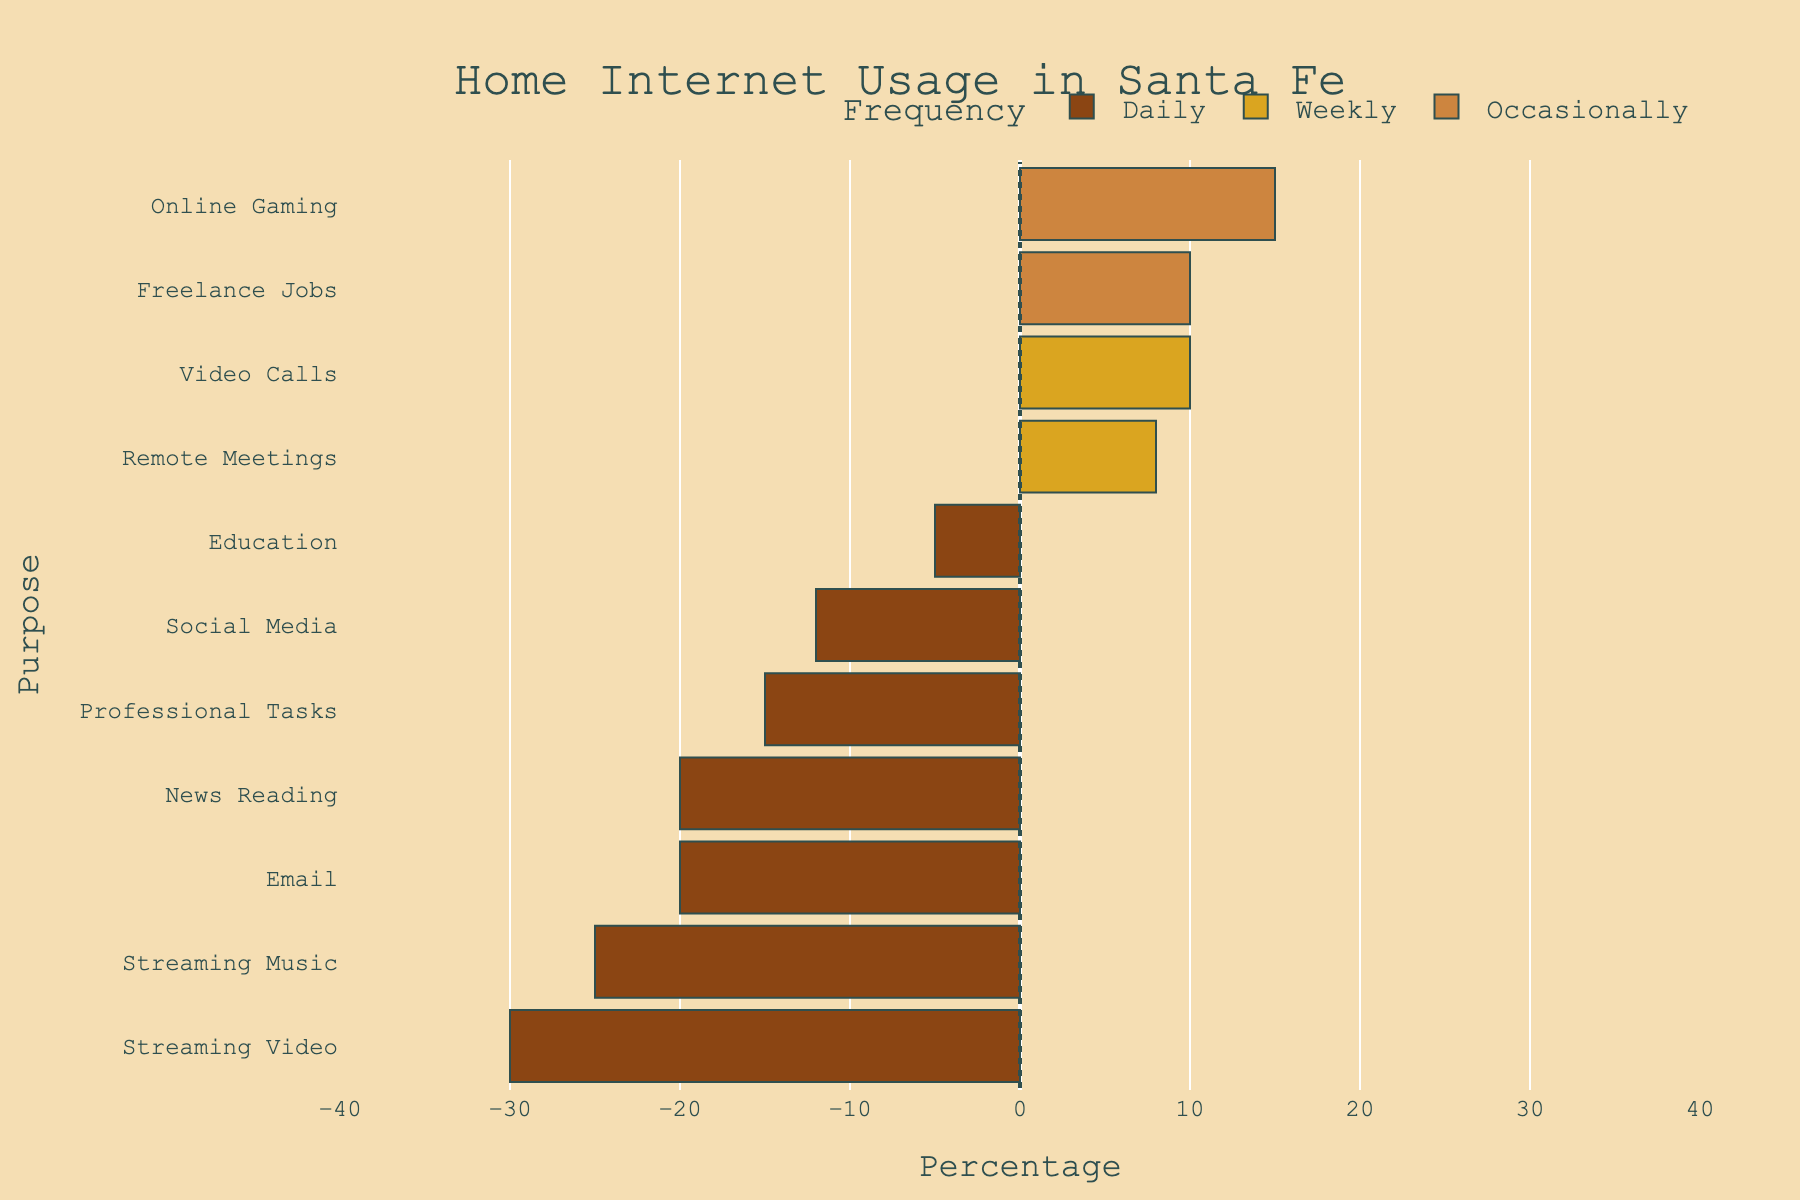What percentage of daily internet use is for professional tasks? Look at the negative bars, which represent daily usage, and find the one with the label "Professional Tasks." The length of this bar indicates the percentage.
Answer: 15% How much more popular is streaming video compared to streaming music for daily use? Identify the daily use bars for "Streaming Video" and "Streaming Music." "Streaming Video" is at -30%, and "Streaming Music" is at -25%. Subtract the values: 30 - 25 = 5%.
Answer: 5% Which category shows the least frequent usage for communication purposes? Look at the communication bars and compare their positions across frequencies. "Video Calls" appears in the weekly frequency, which is less popular than daily.
Answer: Video Calls What is the total percentage of occasional internet use for all purposes? Add the percentages of occasional usage categories: Freelance Jobs (10%) + Online Gaming (15%) = 25%.
Answer: 25% What percentage of people use the internet daily for news reading? Find the bar for "News Reading" within the daily use category. The percentage indicated by its length gives the answer.
Answer: 20% Which has a higher percentage of weekly use: Remote Meetings or Video Calls? Compare the lengths of the bars for "Remote Meetings" and "Video Calls" within the weekly category. "Remote Meetings" is at 8%, and "Video Calls" is at 10%. Therefore, Video Calls is higher.
Answer: Video Calls Is the percentage of daily email usage higher or lower than that of streaming video? Compare the daily use bars for "Email" and "Streaming Video." Email is at -20%, and Streaming Video is at -30%. Since -20 is further from zero, Email is lower than Streaming Video.
Answer: Lower What is the combined percentage of daily usage across all communication purposes? Sum the percentages of all daily communication purposes: Email (20%) + Social Media (12%) = 32%.
Answer: 32% How does the weekly remote meeting usage compare to weekly video call usage? Compare the weekly bars for "Remote Meetings" and "Video Calls." "Remote Meetings" is at 8%, while "Video Calls" is at 10%. "Video Calls" has a higher percentage.
Answer: Video Calls What percentage of people use the internet daily for both education and professional tasks combined? Add the daily use percentages for "Education" (5%) and "Professional Tasks" (15%) for the combined total. 5 + 15 = 20%.
Answer: 20% 